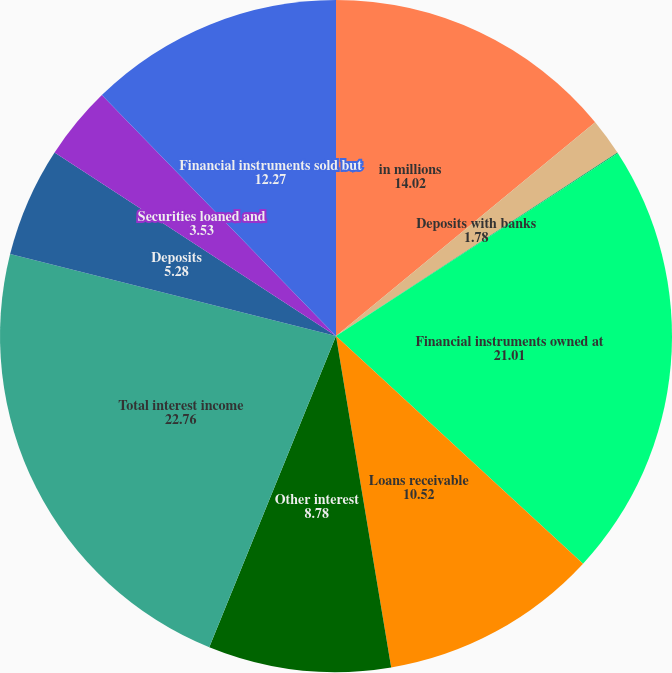<chart> <loc_0><loc_0><loc_500><loc_500><pie_chart><fcel>in millions<fcel>Deposits with banks<fcel>Securities borrowed securities<fcel>Financial instruments owned at<fcel>Loans receivable<fcel>Other interest<fcel>Total interest income<fcel>Deposits<fcel>Securities loaned and<fcel>Financial instruments sold but<nl><fcel>14.02%<fcel>1.78%<fcel>0.04%<fcel>21.01%<fcel>10.52%<fcel>8.78%<fcel>22.76%<fcel>5.28%<fcel>3.53%<fcel>12.27%<nl></chart> 